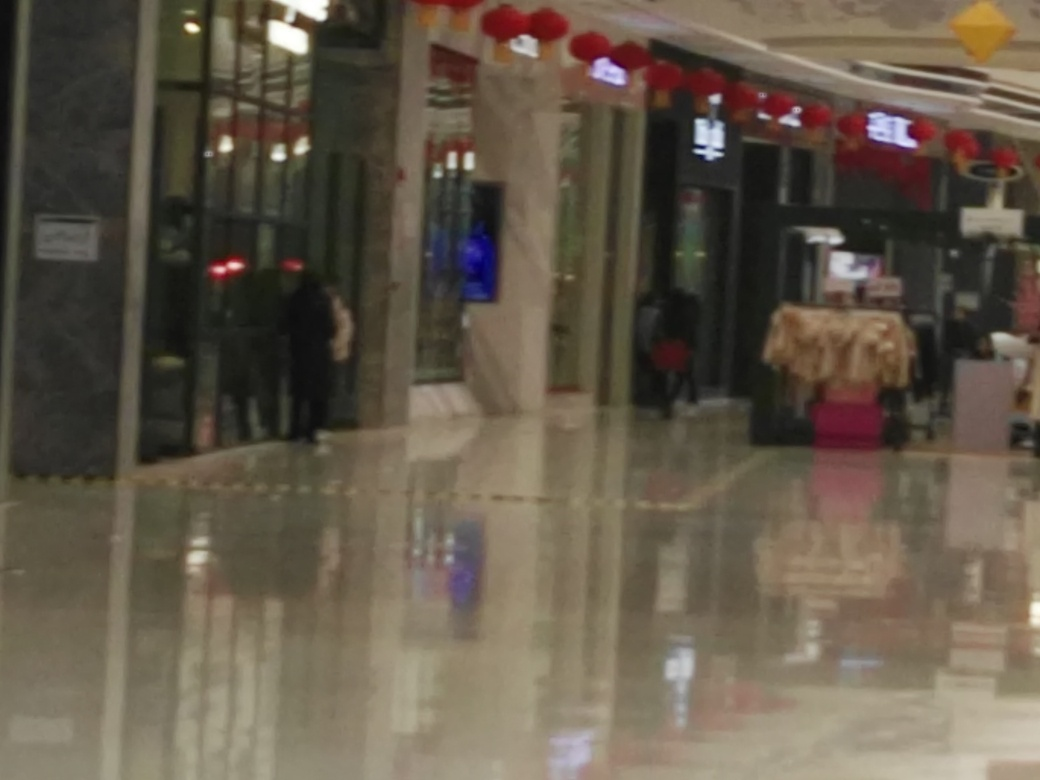What is the problem with the image quality?
A. The image has focusing problems and appears blurry.
B. The image has no focusing problems and is clear.
C. The image has exposure problems and appears overexposed.
Answer with the option's letter from the given choices directly.
 A. 